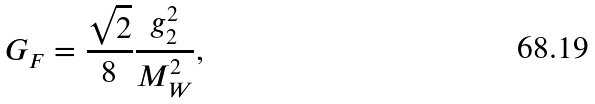Convert formula to latex. <formula><loc_0><loc_0><loc_500><loc_500>G _ { F } = \frac { \sqrt { 2 } } { 8 } \frac { g _ { 2 } ^ { 2 } } { M _ { W } ^ { 2 } } ,</formula> 